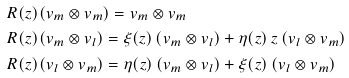<formula> <loc_0><loc_0><loc_500><loc_500>R ( z ) & ( v _ { m } \otimes v _ { m } ) = v _ { m } \otimes v _ { m } \\ R ( z ) & ( v _ { m } \otimes v _ { l } ) = \xi ( z ) \, ( v _ { m } \otimes v _ { l } ) + \eta ( z ) \, z \, ( v _ { l } \otimes v _ { m } ) \\ R ( z ) & ( v _ { l } \otimes v _ { m } ) = \eta ( z ) \, ( v _ { m } \otimes v _ { l } ) + \xi ( z ) \, ( v _ { l } \otimes v _ { m } )</formula> 